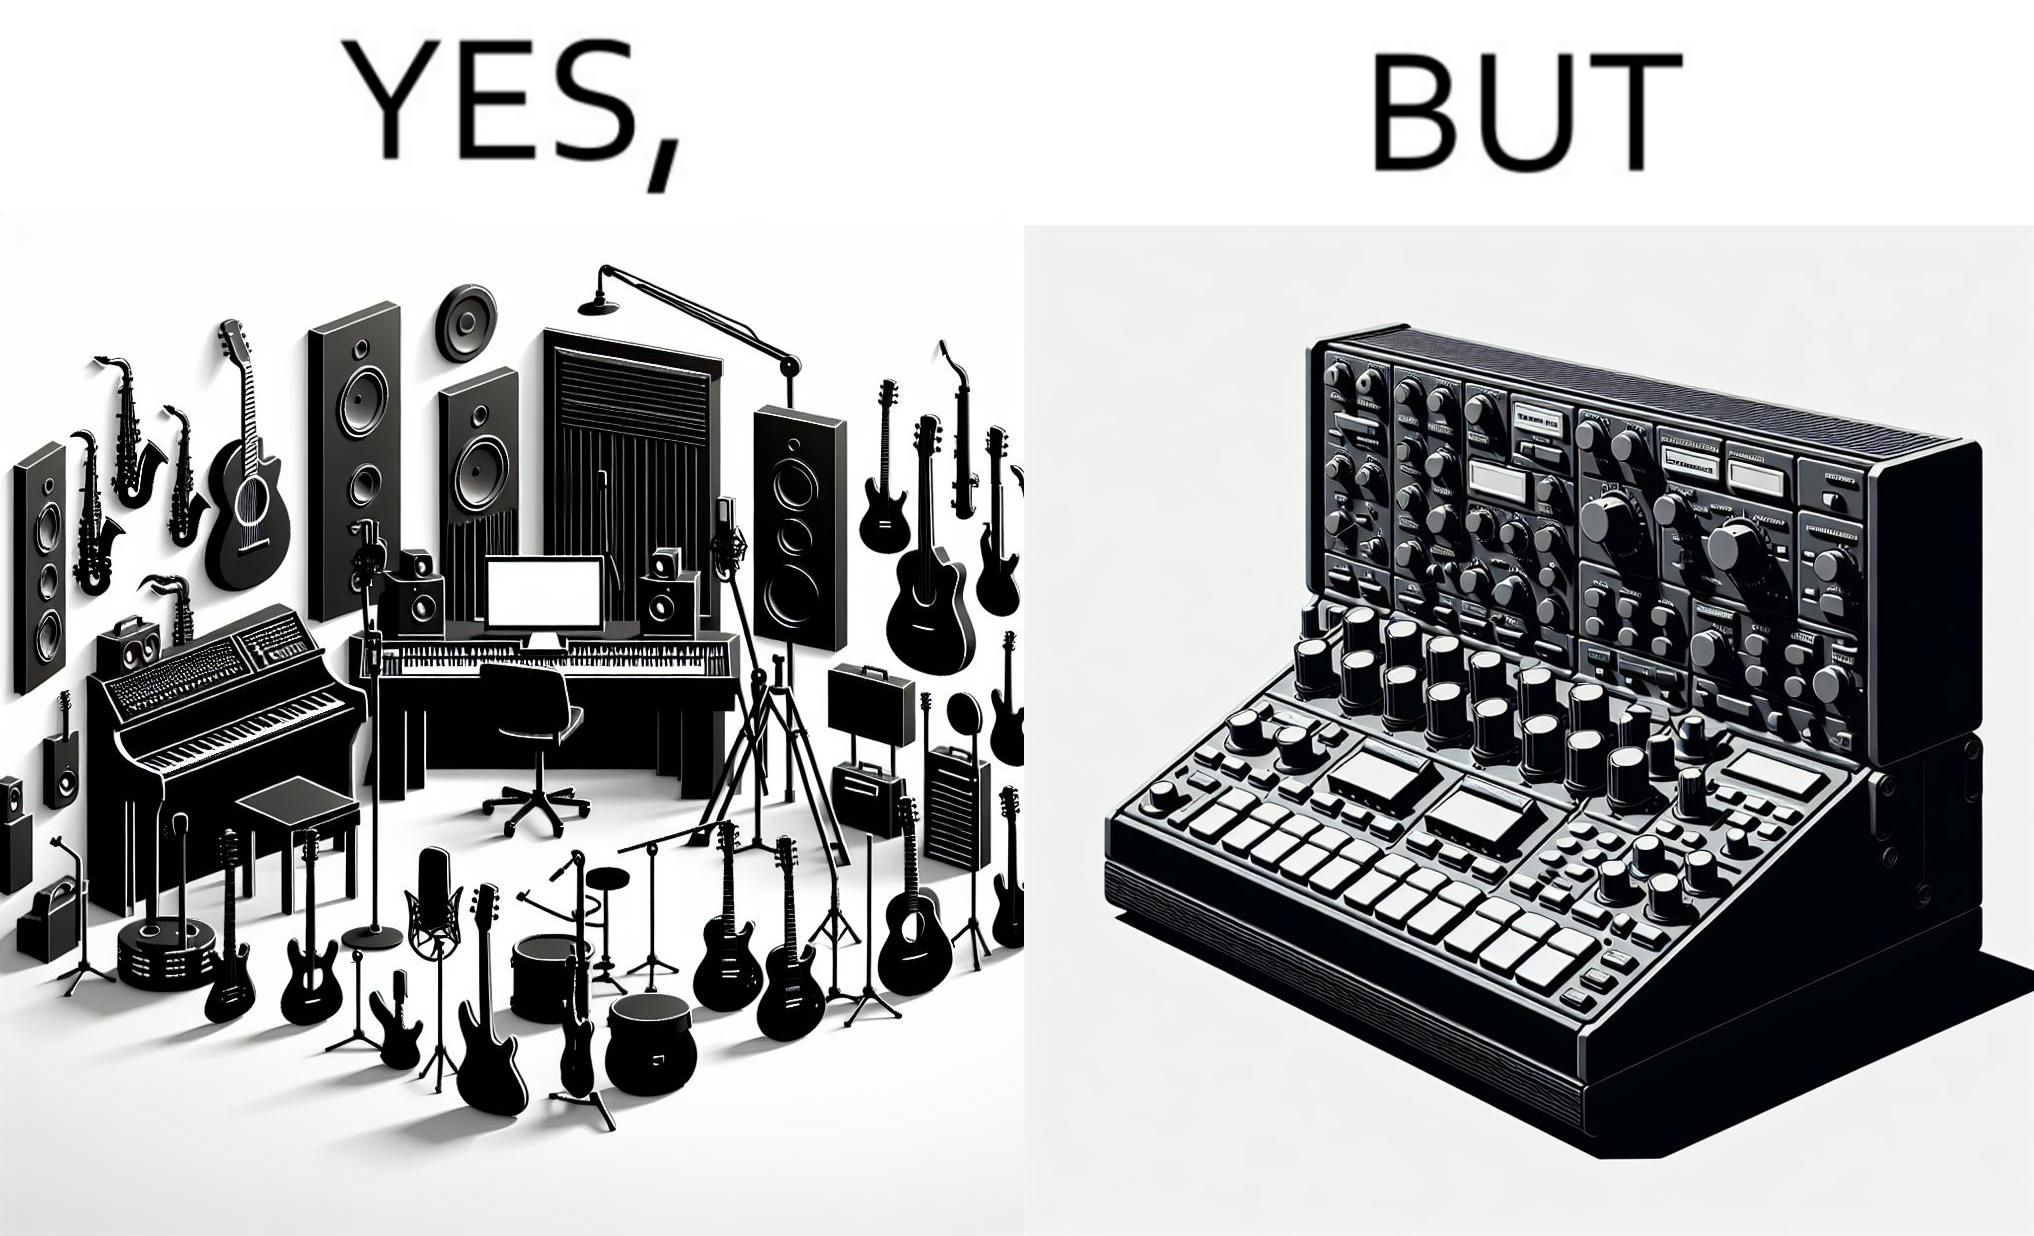Describe what you see in the left and right parts of this image. In the left part of the image: The image shows a music studio with differnt kinds of instruments like guitar and saxophone, piano and recording  to make music. In the right part of the image: The image shows the view of an electornic equipment used to create music. It has buttons to record, play drums and other musical instruments. 